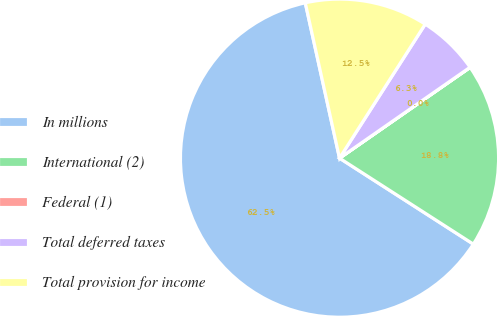<chart> <loc_0><loc_0><loc_500><loc_500><pie_chart><fcel>In millions<fcel>International (2)<fcel>Federal (1)<fcel>Total deferred taxes<fcel>Total provision for income<nl><fcel>62.45%<fcel>18.75%<fcel>0.02%<fcel>6.26%<fcel>12.51%<nl></chart> 